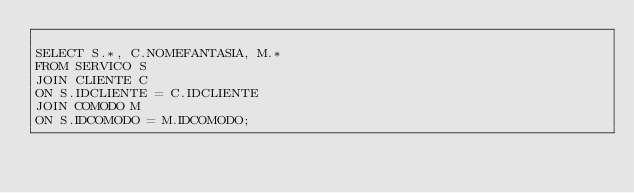<code> <loc_0><loc_0><loc_500><loc_500><_SQL_>
SELECT S.*, C.NOMEFANTASIA, M.* 
FROM SERVICO S 
JOIN CLIENTE C
ON S.IDCLIENTE = C.IDCLIENTE
JOIN COMODO M 
ON S.IDCOMODO = M.IDCOMODO;</code> 